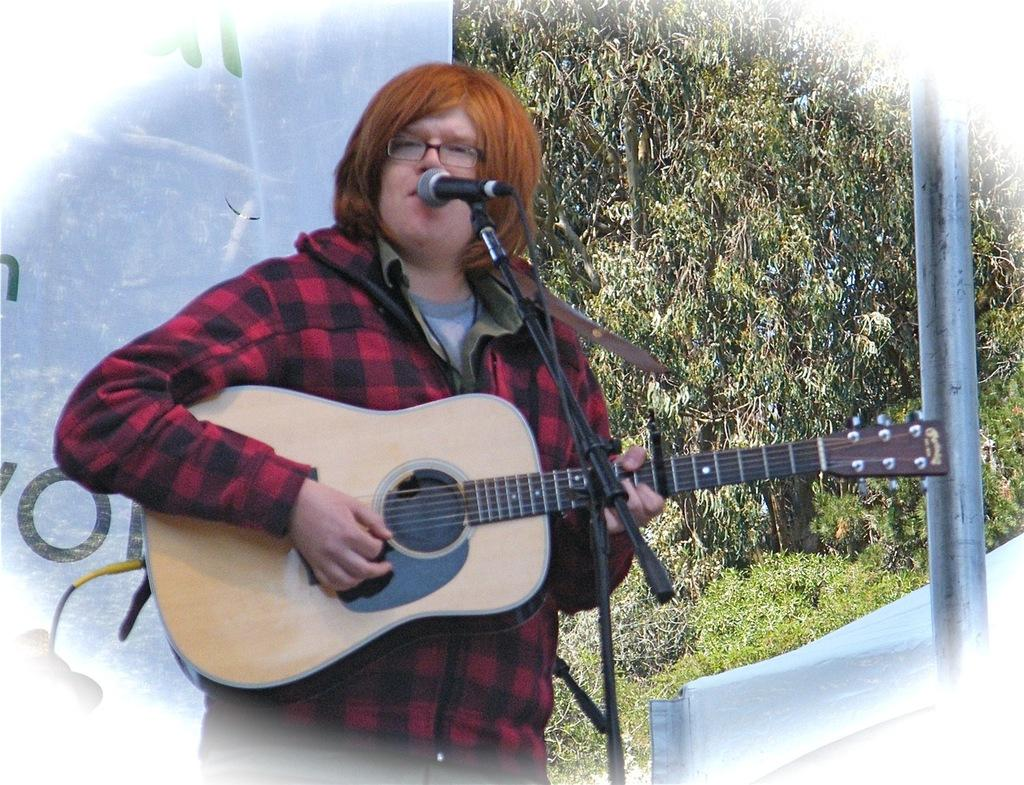What is the person in the image doing? The person is playing a guitar and singing in-front of a microphone. What can be seen in the background of the image? There are trees visible in the image. What object is present in the image that is not related to the person's performance? There is a pole in the image. How much writing is visible on the guitar in the image? There is no writing visible on the guitar in the image. What time of day is it in the image? The time of day cannot be determined from the image alone. 